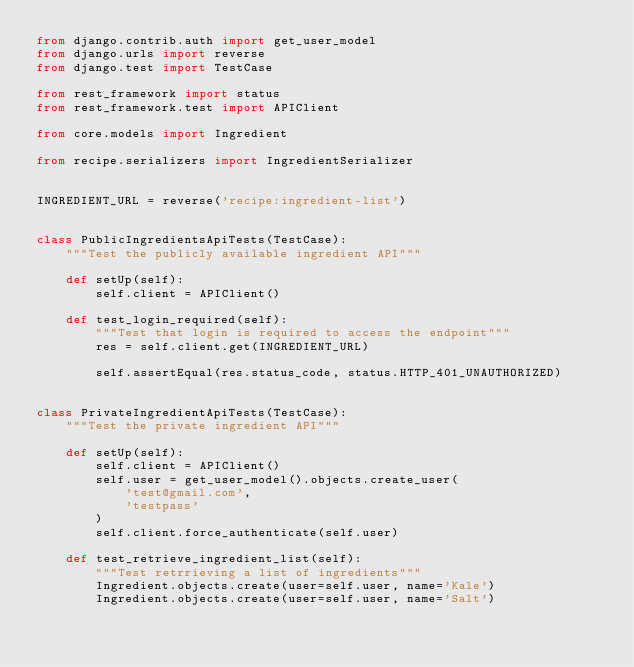<code> <loc_0><loc_0><loc_500><loc_500><_Python_>from django.contrib.auth import get_user_model
from django.urls import reverse
from django.test import TestCase

from rest_framework import status
from rest_framework.test import APIClient

from core.models import Ingredient

from recipe.serializers import IngredientSerializer


INGREDIENT_URL = reverse('recipe:ingredient-list')


class PublicIngredientsApiTests(TestCase):
    """Test the publicly available ingredient API"""

    def setUp(self):
        self.client = APIClient()

    def test_login_required(self):
        """Test that login is required to access the endpoint"""
        res = self.client.get(INGREDIENT_URL)

        self.assertEqual(res.status_code, status.HTTP_401_UNAUTHORIZED)


class PrivateIngredientApiTests(TestCase):
    """Test the private ingredient API"""

    def setUp(self):
        self.client = APIClient()
        self.user = get_user_model().objects.create_user(
            'test@gmail.com',
            'testpass'
        )
        self.client.force_authenticate(self.user)

    def test_retrieve_ingredient_list(self):
        """Test retrrieving a list of ingredients"""
        Ingredient.objects.create(user=self.user, name='Kale')
        Ingredient.objects.create(user=self.user, name='Salt')
</code> 